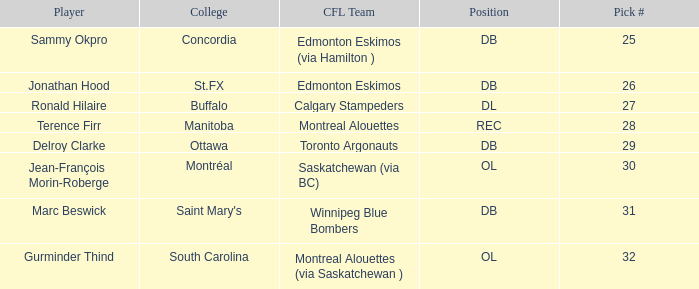What is buffalo's pick #? 27.0. Could you parse the entire table as a dict? {'header': ['Player', 'College', 'CFL Team', 'Position', 'Pick #'], 'rows': [['Sammy Okpro', 'Concordia', 'Edmonton Eskimos (via Hamilton )', 'DB', '25'], ['Jonathan Hood', 'St.FX', 'Edmonton Eskimos', 'DB', '26'], ['Ronald Hilaire', 'Buffalo', 'Calgary Stampeders', 'DL', '27'], ['Terence Firr', 'Manitoba', 'Montreal Alouettes', 'REC', '28'], ['Delroy Clarke', 'Ottawa', 'Toronto Argonauts', 'DB', '29'], ['Jean-François Morin-Roberge', 'Montréal', 'Saskatchewan (via BC)', 'OL', '30'], ['Marc Beswick', "Saint Mary's", 'Winnipeg Blue Bombers', 'DB', '31'], ['Gurminder Thind', 'South Carolina', 'Montreal Alouettes (via Saskatchewan )', 'OL', '32']]} 